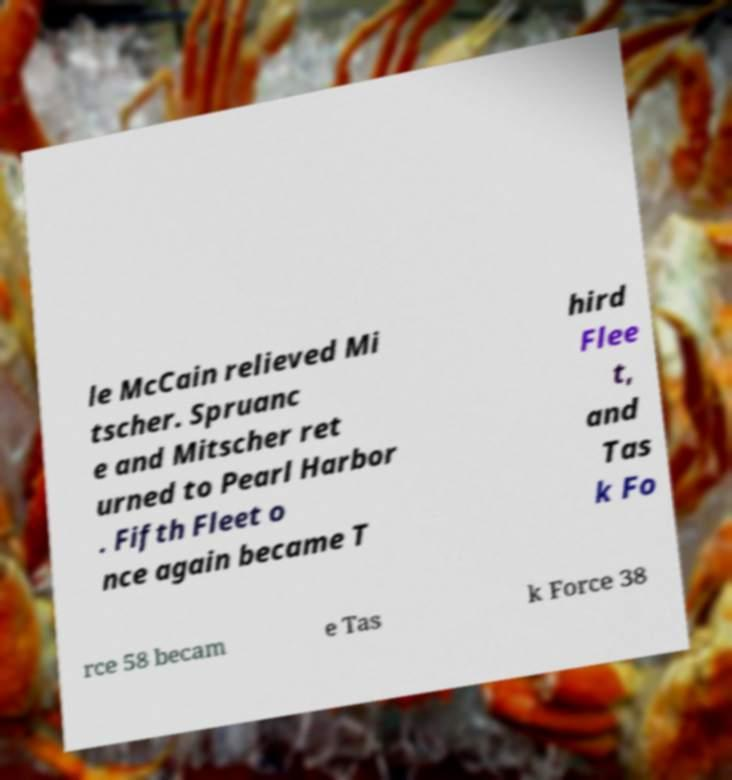There's text embedded in this image that I need extracted. Can you transcribe it verbatim? le McCain relieved Mi tscher. Spruanc e and Mitscher ret urned to Pearl Harbor . Fifth Fleet o nce again became T hird Flee t, and Tas k Fo rce 58 becam e Tas k Force 38 